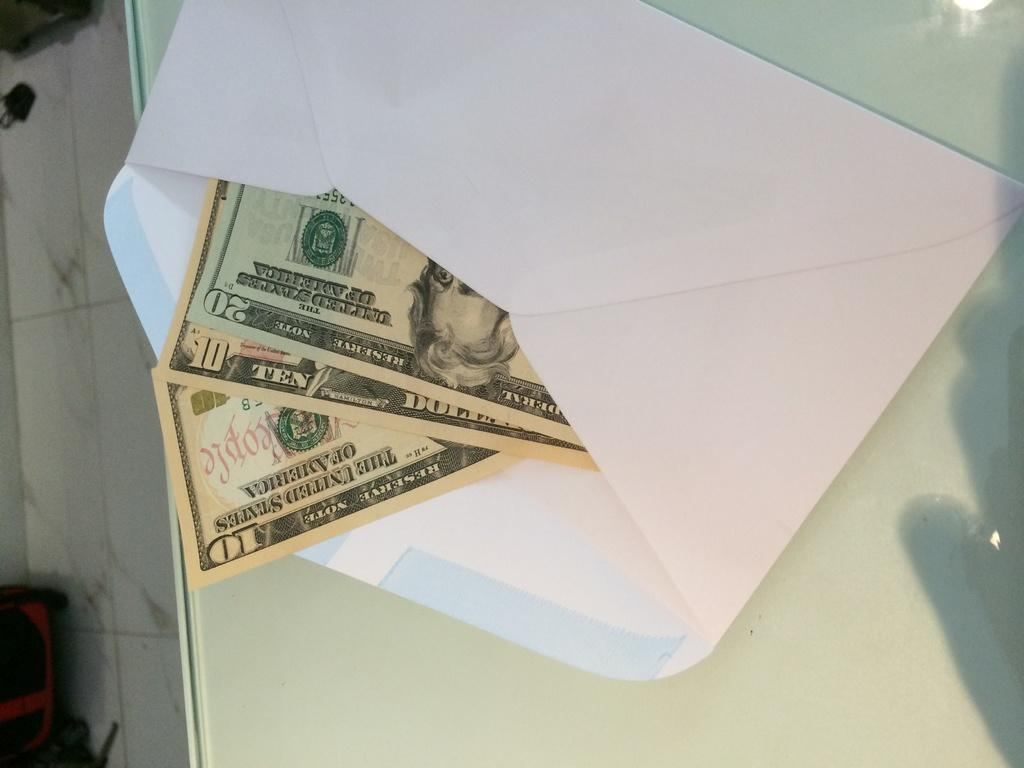<image>
Describe the image concisely. two 10 Dollar and one 20 Reserve Note in a white envelope 